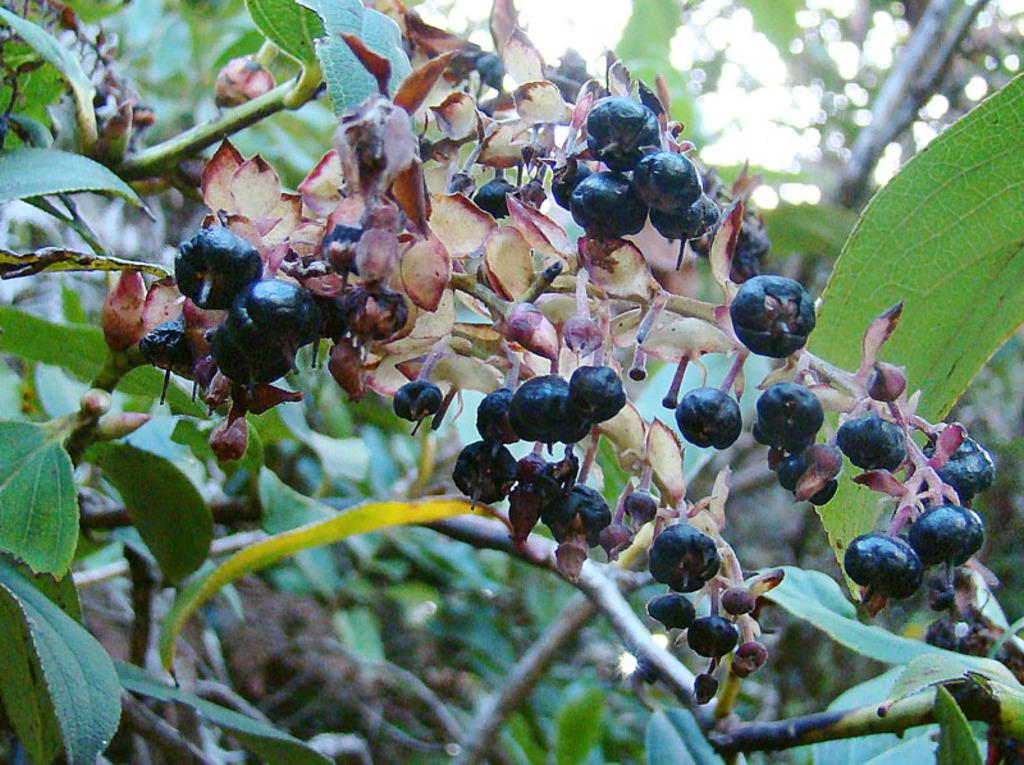What type of tree is present in the image? There is a borrachera fruit tree in the image. What can be found on the tree? The tree has fruits and buds. How many ladybugs can be seen on the tree in the image? There are no ladybugs present in the image; it only features a borrachera fruit tree with fruits and buds. What type of organization is responsible for maintaining the tree in the image? There is no information about an organization responsible for maintaining the tree in the image. 